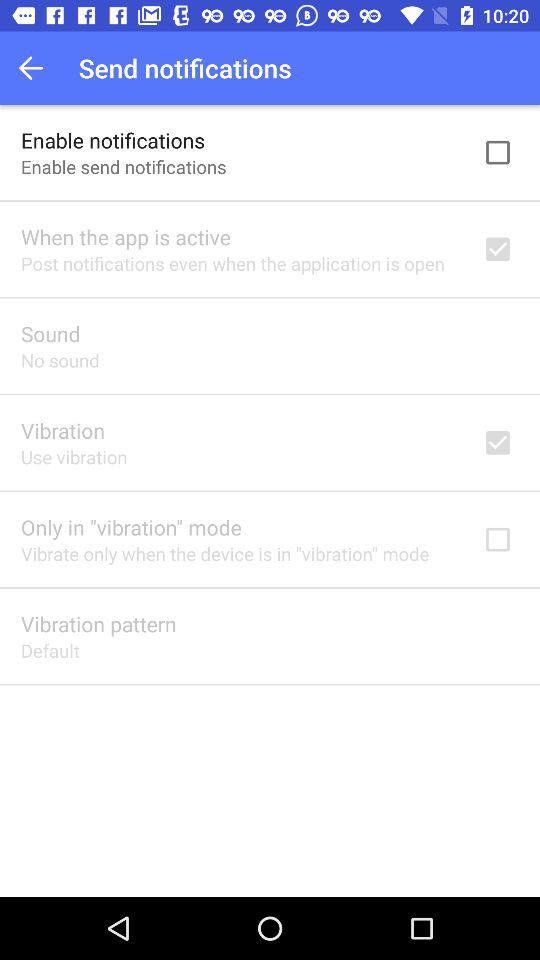What is the setting for sound? The setting for sound is "No sound". 